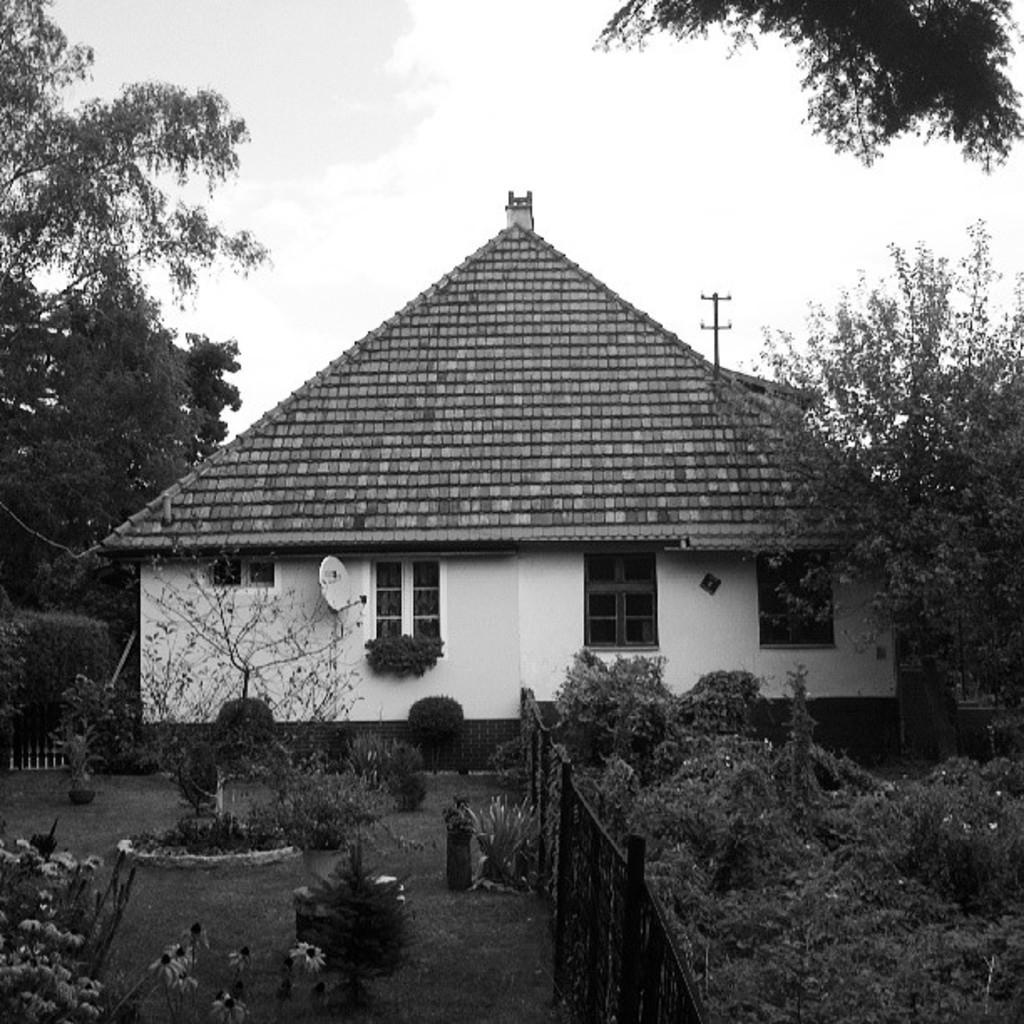Please provide a concise description of this image. In the image we can see there are plants on the ground and the ground is covered with grass. There are plants and bushes on the ground. Behind there is a hut shaped building and there are trees. There is a clear sky. 